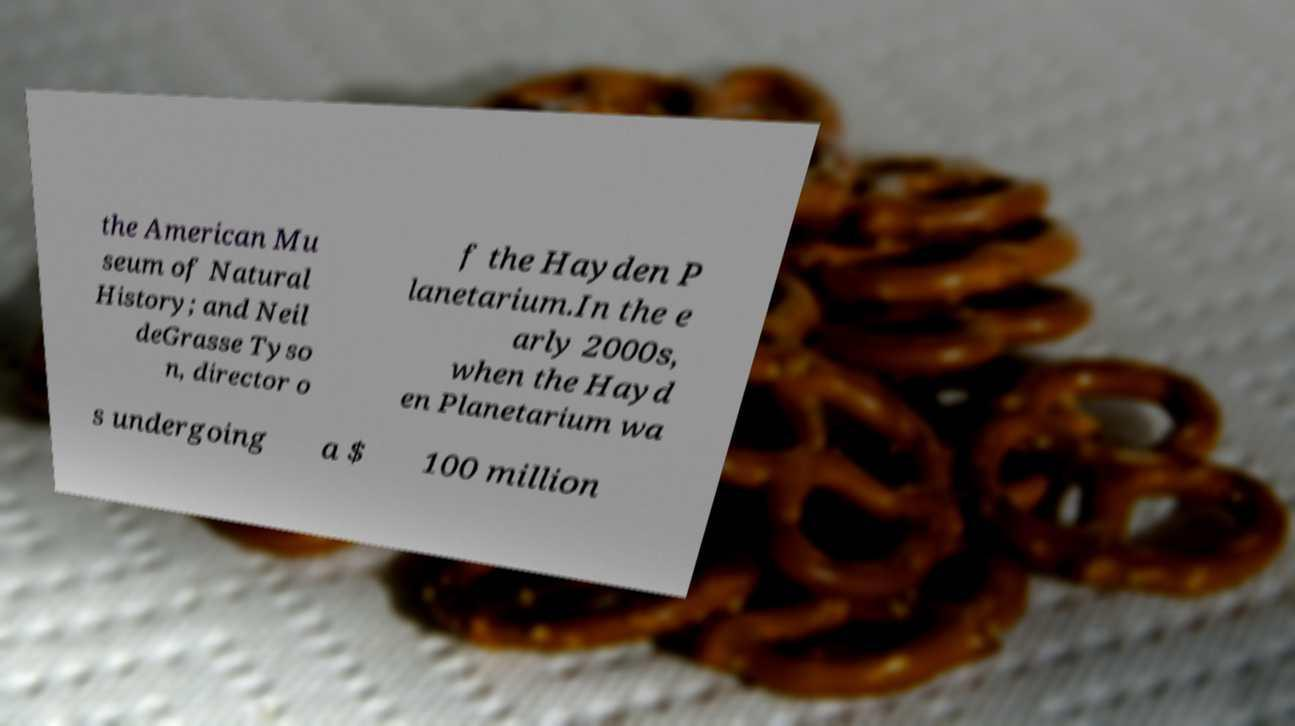What messages or text are displayed in this image? I need them in a readable, typed format. the American Mu seum of Natural History; and Neil deGrasse Tyso n, director o f the Hayden P lanetarium.In the e arly 2000s, when the Hayd en Planetarium wa s undergoing a $ 100 million 